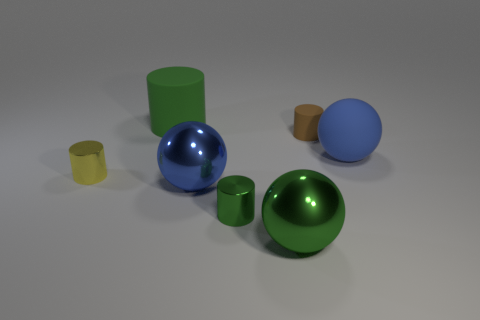Subtract 1 cylinders. How many cylinders are left? 3 Add 2 small brown things. How many objects exist? 9 Subtract all brown cylinders. Subtract all green spheres. How many cylinders are left? 3 Subtract all spheres. How many objects are left? 4 Subtract all big green metal objects. Subtract all large metal balls. How many objects are left? 4 Add 3 big green matte objects. How many big green matte objects are left? 4 Add 3 big balls. How many big balls exist? 6 Subtract 0 gray cylinders. How many objects are left? 7 